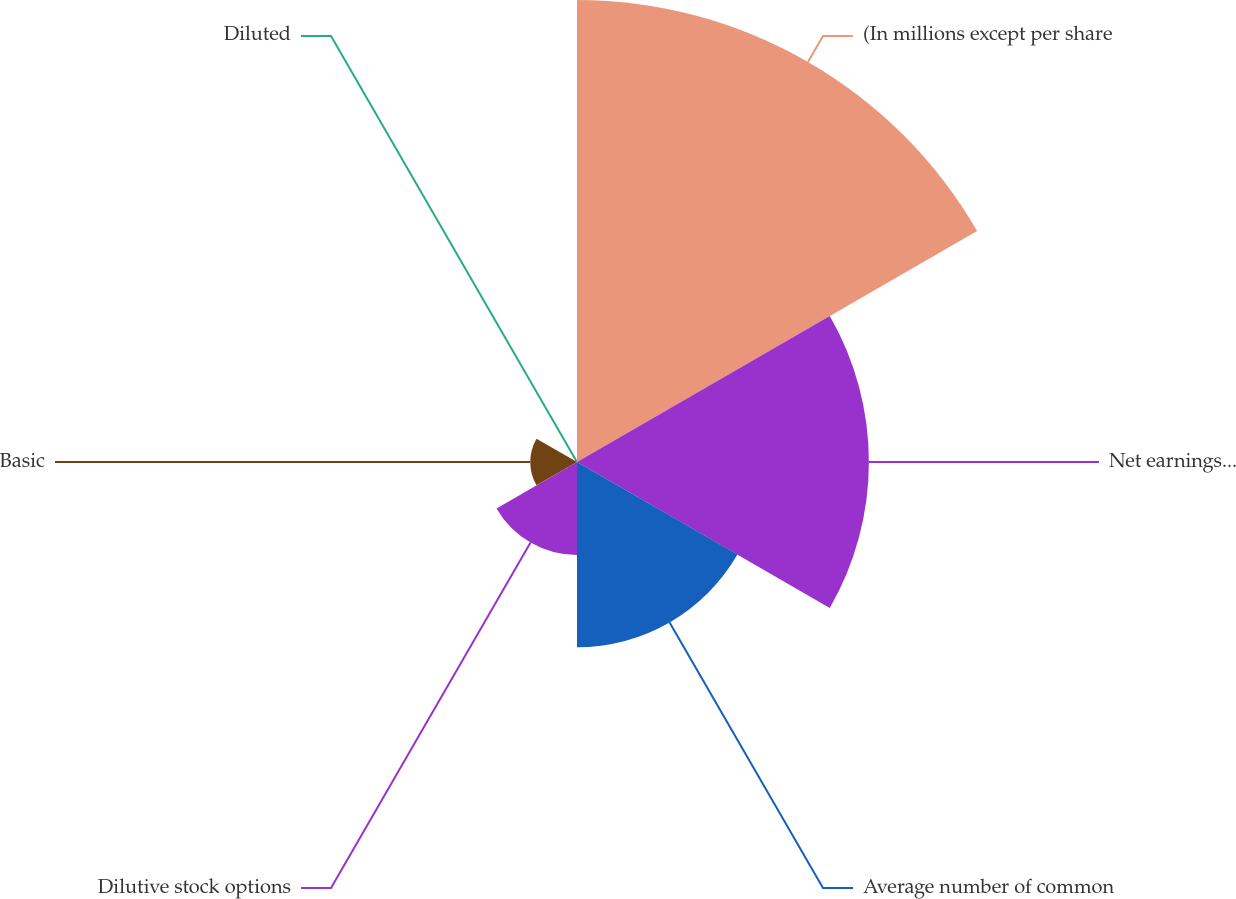Convert chart. <chart><loc_0><loc_0><loc_500><loc_500><pie_chart><fcel>(In millions except per share<fcel>Net earnings for basic and<fcel>Average number of common<fcel>Dilutive stock options<fcel>Basic<fcel>Diluted<nl><fcel>42.8%<fcel>27.04%<fcel>17.16%<fcel>8.61%<fcel>4.33%<fcel>0.06%<nl></chart> 